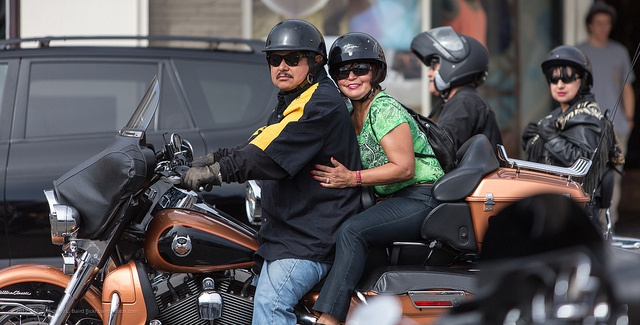Describe the objects in this image and their specific colors. I can see motorcycle in black, gray, brown, and maroon tones, car in black and gray tones, people in black, gray, and lightblue tones, people in black, blue, and brown tones, and people in black and gray tones in this image. 